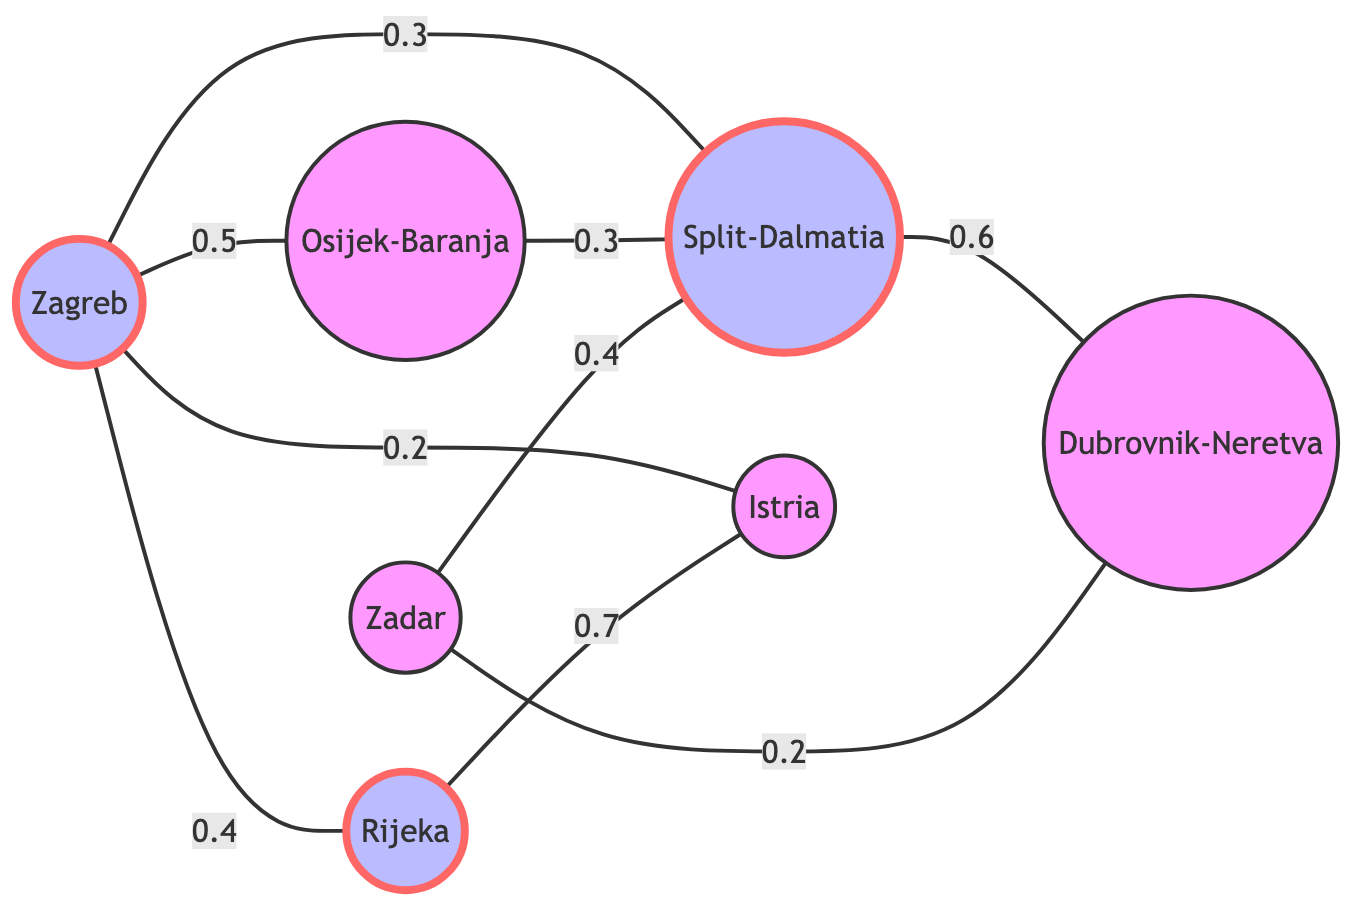What is the total number of counties represented in the graph? The graph shows 7 nodes representing different counties: Zagreb, Split-Dalmatia, Istria, Rijeka, Osijek-Baranja, Zadar, and Dubrovnik-Neretva. Adding these together gives a total of 7 counties.
Answer: 7 Which county has the highest connection weight to Rijeka? The edge between Rijeka and Istria has a weight of 0.7, which is the highest connection weight involving Rijeka. Thus, Istria is determined to be the county with the highest connection weight to Rijeka.
Answer: Istria What is the migration weight from Osijek-Baranja to Split-Dalmatia? The connection between Osijek-Baranja and Split-Dalmatia has a weight of 0.3, which directly answers the question about migration weight between these two counties.
Answer: 0.3 Which two counties share a connection with the highest weight? The link between Rijeka and Istria has the highest weight of 0.7. Therefore, Rijeka and Istria share the connection with the highest migration weight.
Answer: Rijeka and Istria Is there a direct migration connection between Zadar and Osijek-Baranja? There is no direct link between Zadar and Osijek-Baranja in the graph. Upon checking the connections, no edge is found between these two counties.
Answer: No Which county is connected to Split-Dalmatia with the lowest migration weight? Among the connections to Split-Dalmatia, the migration weight from Zadar to Split-Dalmatia is 0.4, which is the lowest when compared to the other connections.
Answer: Zadar How many connections does Zagreb have? The graph shows that Zagreb has links to Split-Dalmatia, Istria, Rijeka, and Osijek-Baranja, resulting in a total of 4 connections. Count these edges to confirm.
Answer: 4 Which two counties are connected to Dubrovnik-Neretva? Looking at the graph, we see that Dubrovnik-Neretva has connections to Split-Dalmatia and Zadar based on the edges listed.
Answer: Split-Dalmatia and Zadar 